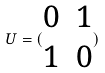Convert formula to latex. <formula><loc_0><loc_0><loc_500><loc_500>U = ( \begin{matrix} 0 & 1 \\ 1 & 0 \end{matrix} )</formula> 